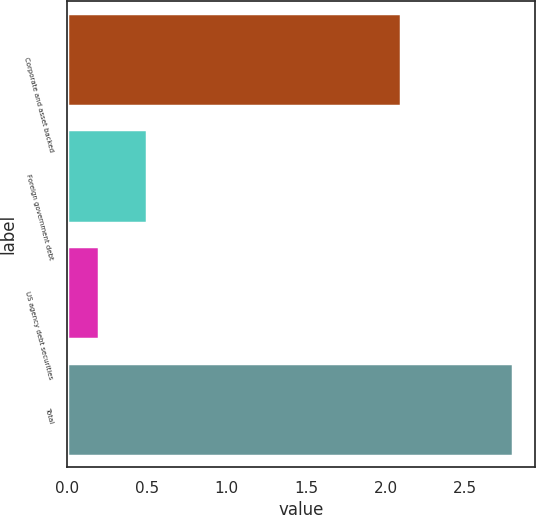Convert chart. <chart><loc_0><loc_0><loc_500><loc_500><bar_chart><fcel>Corporate and asset backed<fcel>Foreign government debt<fcel>US agency debt securities<fcel>Total<nl><fcel>2.1<fcel>0.5<fcel>0.2<fcel>2.8<nl></chart> 